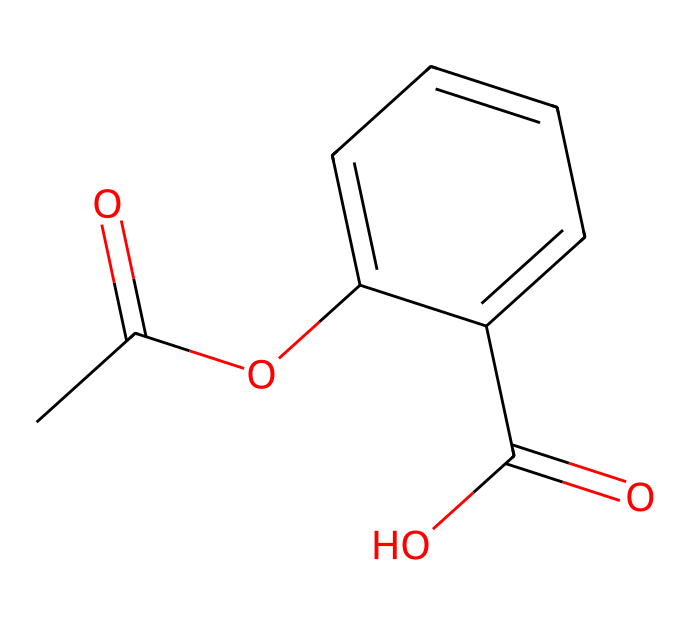What is the molecular formula of aspirin? To determine the molecular formula, we count the different types of atoms present in the SMILES representation. The structure contains 9 carbon atoms (C), 8 hydrogen atoms (H), and 4 oxygen atoms (O). Thus, the molecular formula is C9H8O4.
Answer: C9H8O4 How many carbon atoms are in the aspirin molecule? In the SMILES representation, we identify that there are 9 carbon atoms present throughout the entire structure.
Answer: 9 What functional groups are present in aspirin? By examining the SMILES structure, we can identify the functional groups. Aspirin contains an acetyl group (indicated by CC(=O)O) and a carboxylic acid group (indicated by C(=O)O). Therefore, the functional groups are an ester and a carboxylic acid.
Answer: ester, carboxylic acid Is aspirin a weak acid or a strong acid? Aspirin is known to be a weak acid due to the presence of the carboxylic acid functional group in its structure. Weak acids partially dissociate in solution, which is characteristic of aspirin.
Answer: weak acid What property of aspirin is indicated by the presence of an acetyl group? The presence of an acetyl group in the structure is indicative of its role as a prodrug, which the body metabolizes into its active form (salicylic acid) after administration. This is important for its pain-relieving properties.
Answer: prodrug Which part of the aspirin molecule is responsible for its anti-inflammatory effect? The anti-inflammatory effect of aspirin is largely attributed to the carboxylic acid (C(=O)O) group. This functional group's ability to interact with enzymes involved in inflammation contributes to aspirin's efficacy in reducing inflammation.
Answer: carboxylic acid 